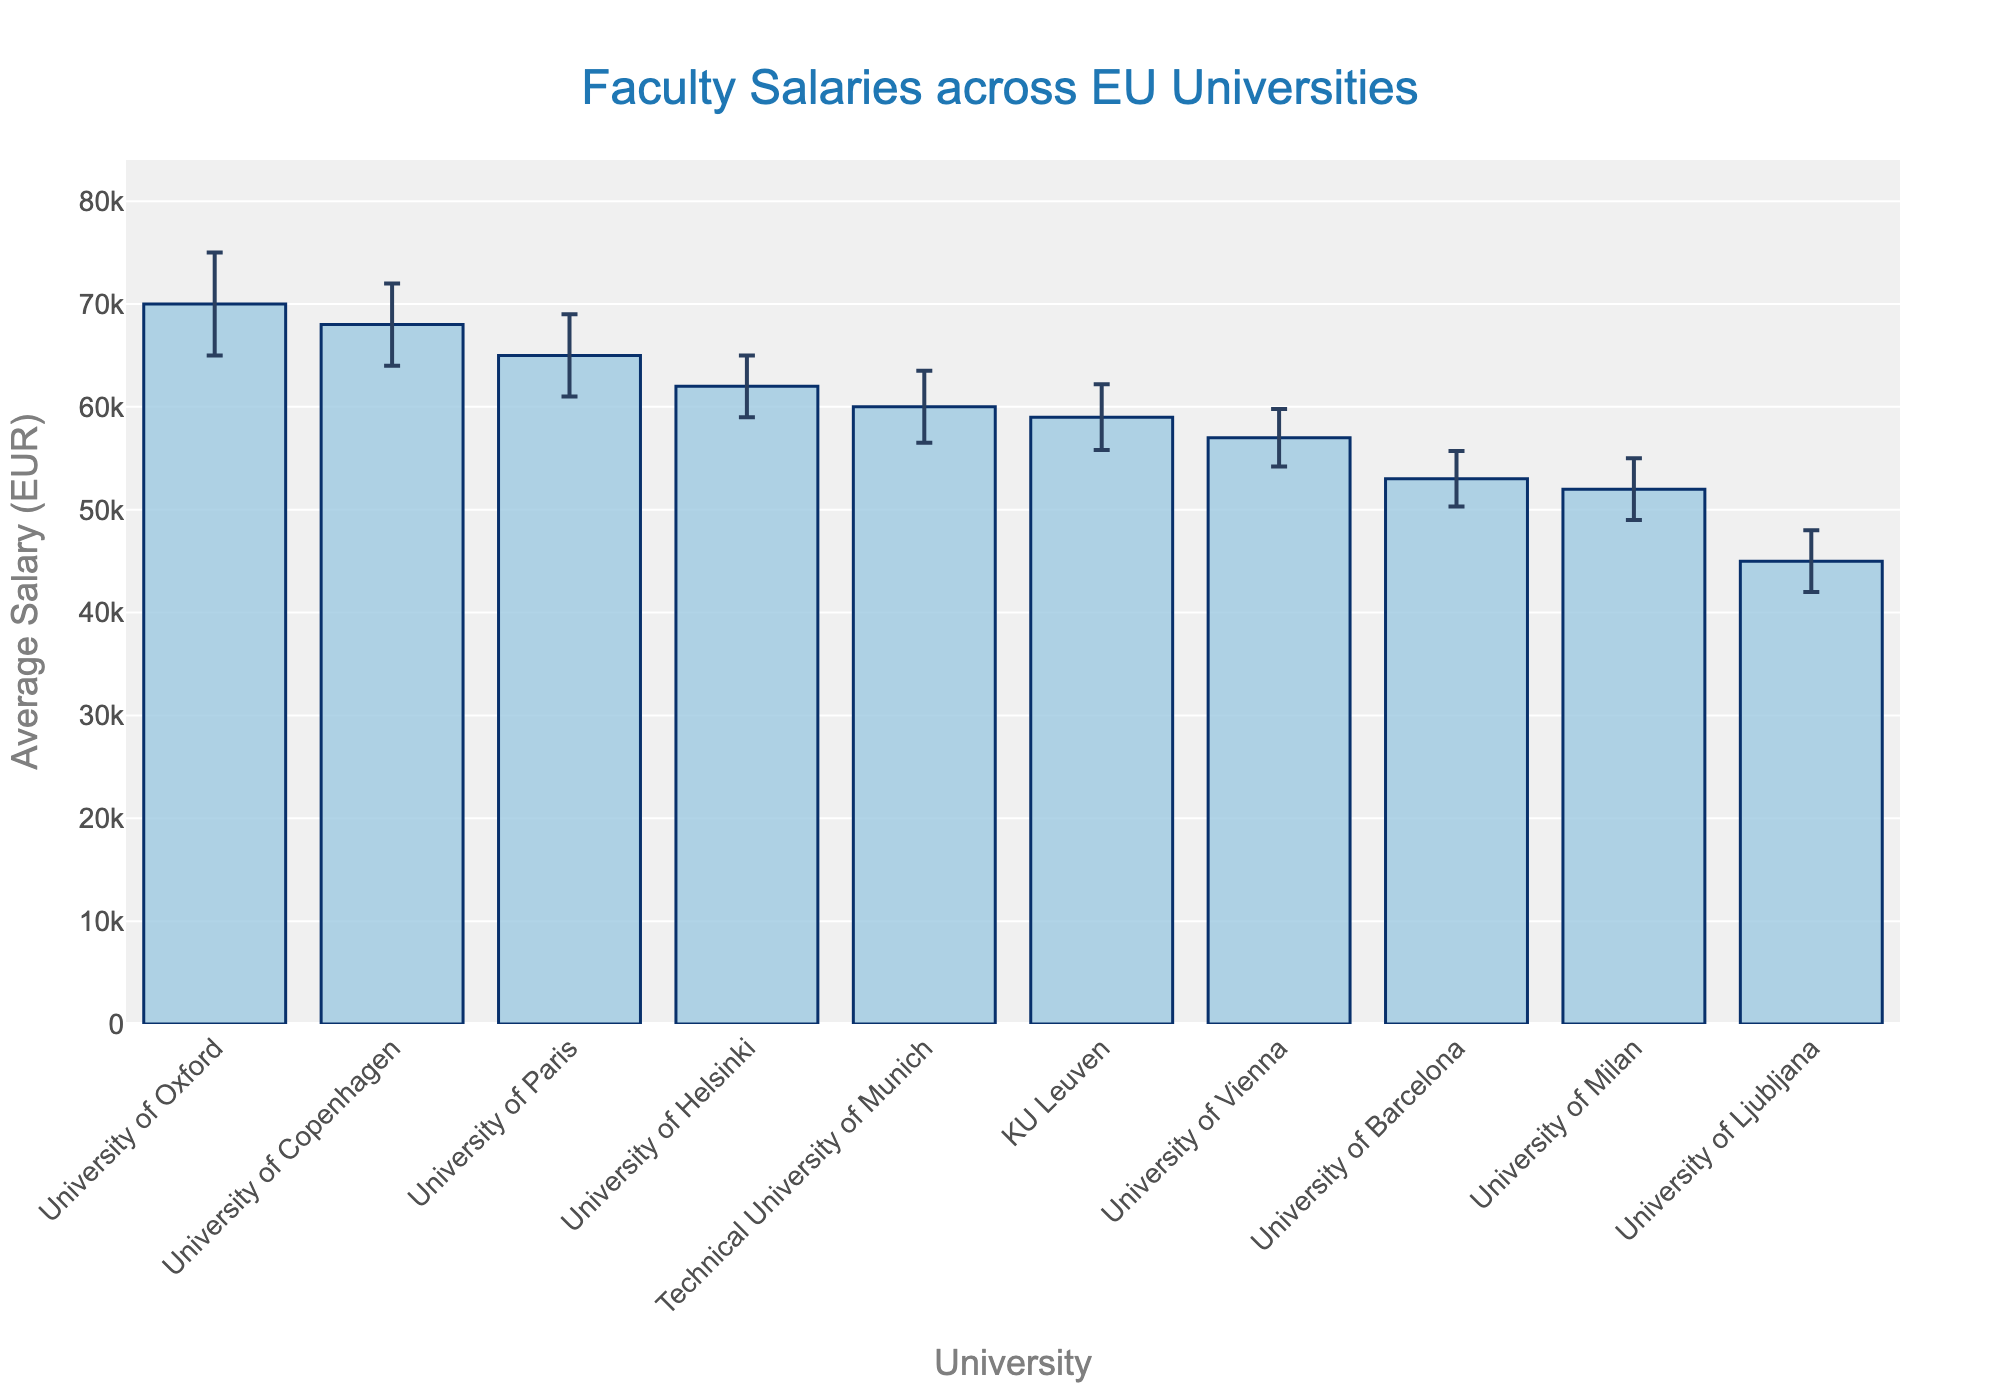What is the title of the chart? The title is typically located at the top of the chart and summarizes the main content. Here, it states the overall topic of the bar chart.
Answer: Faculty Salaries across EU Universities Which university has the highest average salary? Identify the highest bar in the chart, which corresponds to the university with the highest average salary.
Answer: University of Oxford What is the average salary at the University of Ljubljana? Locate the bar labeled "University of Ljubljana" and read the value it represents.
Answer: 45000 EUR How does the average salary of the University of Copenhagen compare to the University of Paris? Compare the heights of the bars labeled "University of Copenhagen" and "University of Paris".
Answer: The University of Copenhagen has a slightly lower average salary than the University of Paris What's the average range of salaries at KU Leuven when including the error margin? Add and subtract the error margin from the average salary of KU Leuven to get the range of salaries.
Answer: 55800 - 62200 EUR Which universities have average salaries above 60000 EUR? Identify all bars with heights exceeding 60000 EUR.
Answer: University of Oxford, University of Paris, University of Copenhagen, University of Helsinki What is the error margin for the University of Barcelona? Find the University of Barcelona's bar and read the error represented by the error bars on top of it.
Answer: 2700 EUR By how much does the average salary at the University of Paris exceed that of the University of Vienna? Subtract the average salary of the University of Vienna from the University of Paris.
Answer: 8000 EUR (65000 - 57000) Arrange the universities in descending order of their average salaries. List the university names based on the height of the bars from tallest to shortest.
Answer: University of Oxford, University of Copenhagen, University of Paris, University of Helsinki, Technical University of Munich, KU Leuven, University of Vienna, University of Barcelona, University of Milan, University of Ljubljana What is the least salary taking into account the error margin for the Technical University of Munich? Subtract the error margin from the average salary of the Technical University of Munich.
Answer: 56500 EUR (60000 - 3500) 